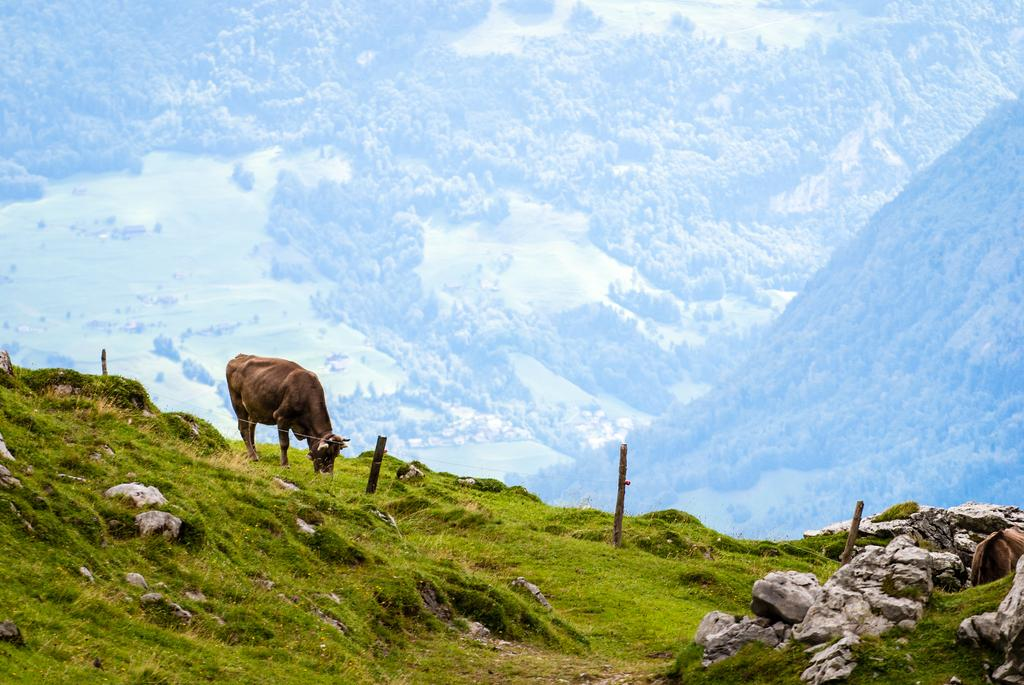What type of animal is in the picture? There is an animal in the picture, but the specific type cannot be determined from the provided facts. What is the animal doing in the image? The animal is grazing grass in the image. Where is the animal located in the image? The animal is on a hill surface in the image. What can be seen in the background of the image? There are mountains in the background of the image. What type of lace is visible on the animal's apparel in the image? There is no mention of apparel or lace in the provided facts, and therefore no such detail can be observed in the image. 